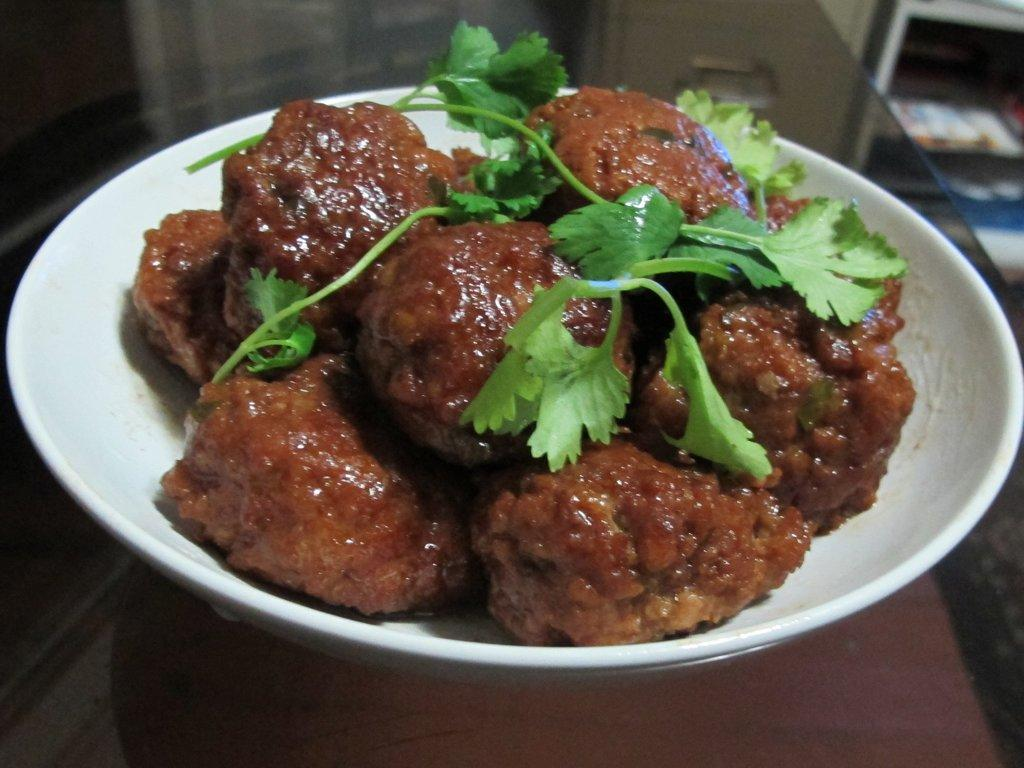What is in the bowl that is visible in the image? There is a bowl containing food in the image. What is placed on the glass table? Coriander leaves are placed on a glass table. Can you describe the object in the right top of the image? There is a blurred rack with many books in the right top of the image. What type of magic trick is being performed with the baby in the image? There is no baby or magic trick present in the image. How does the tramp contribute to the scene in the image? There is no tramp present in the image. 